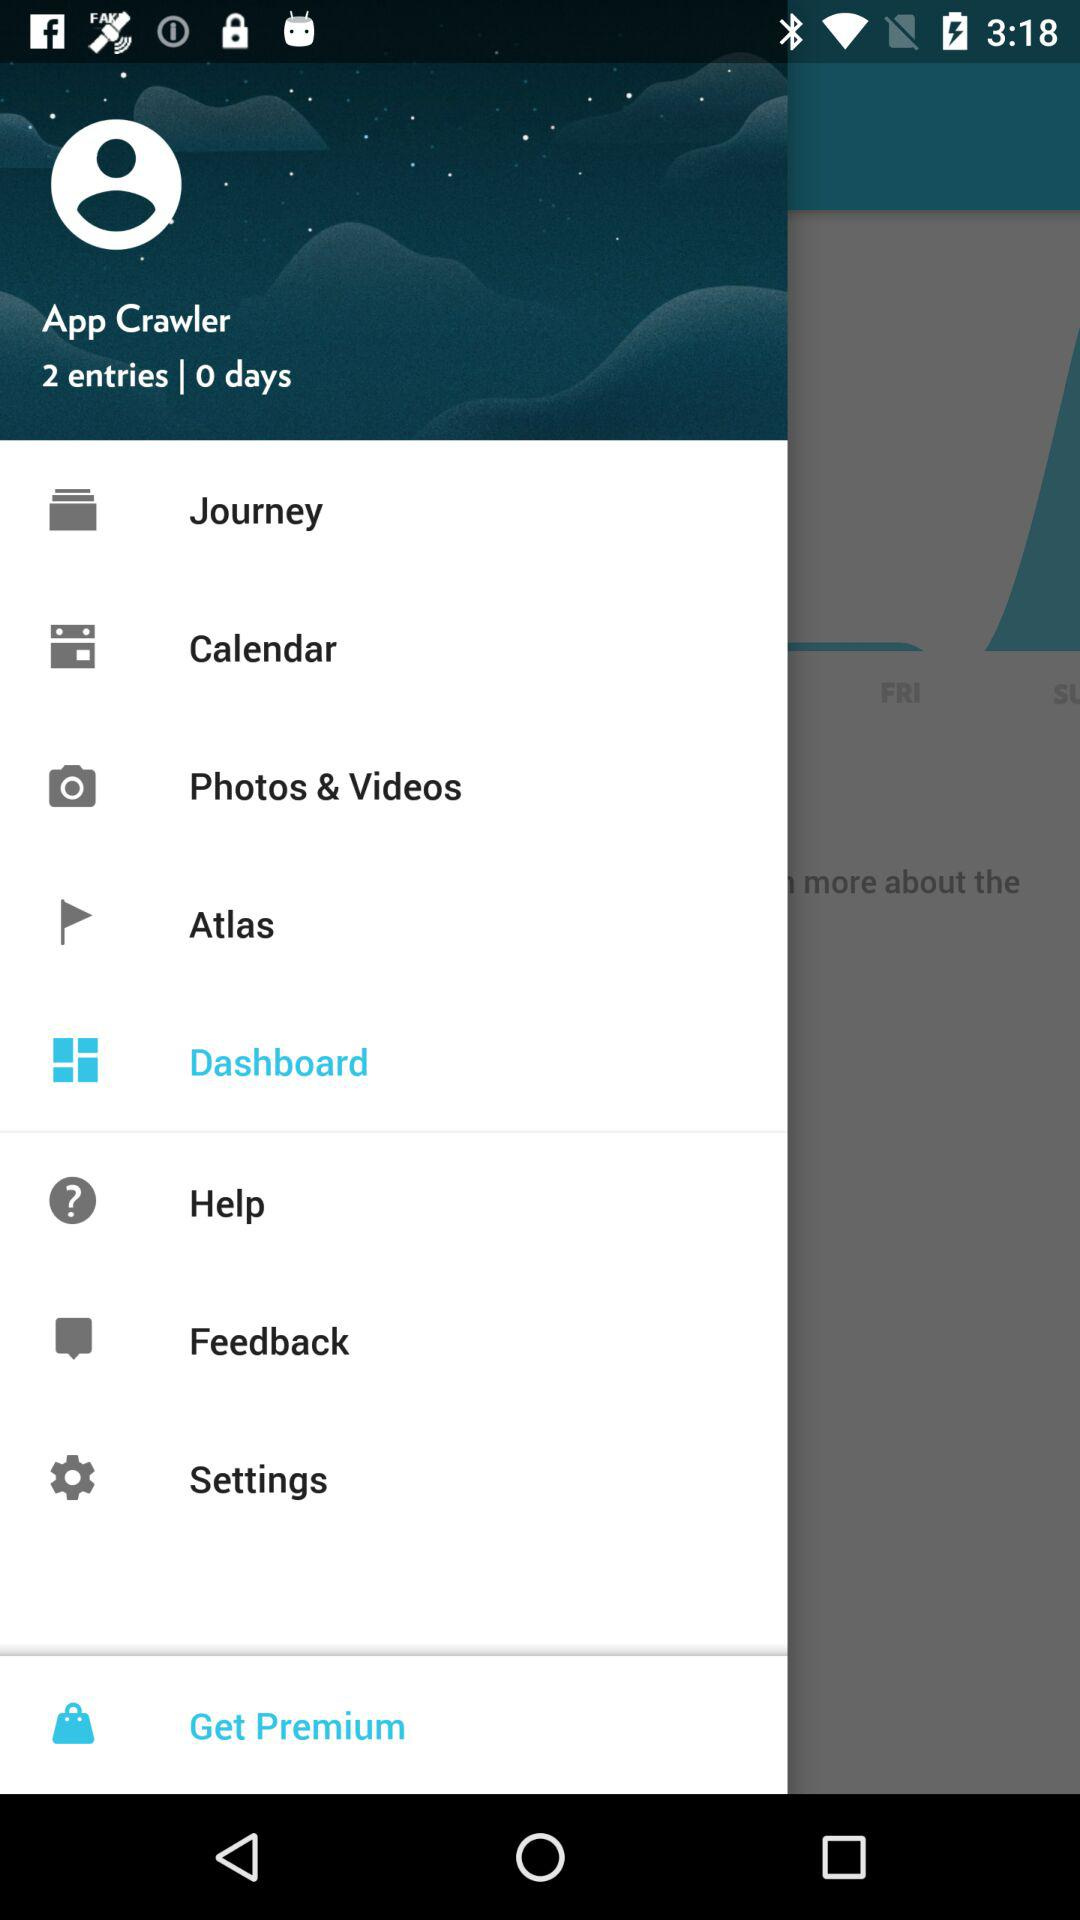How many entries are there? There are 2 entries. 